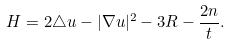<formula> <loc_0><loc_0><loc_500><loc_500>H = 2 \triangle u - | \nabla u | ^ { 2 } - 3 R - \frac { 2 n } { t } .</formula> 